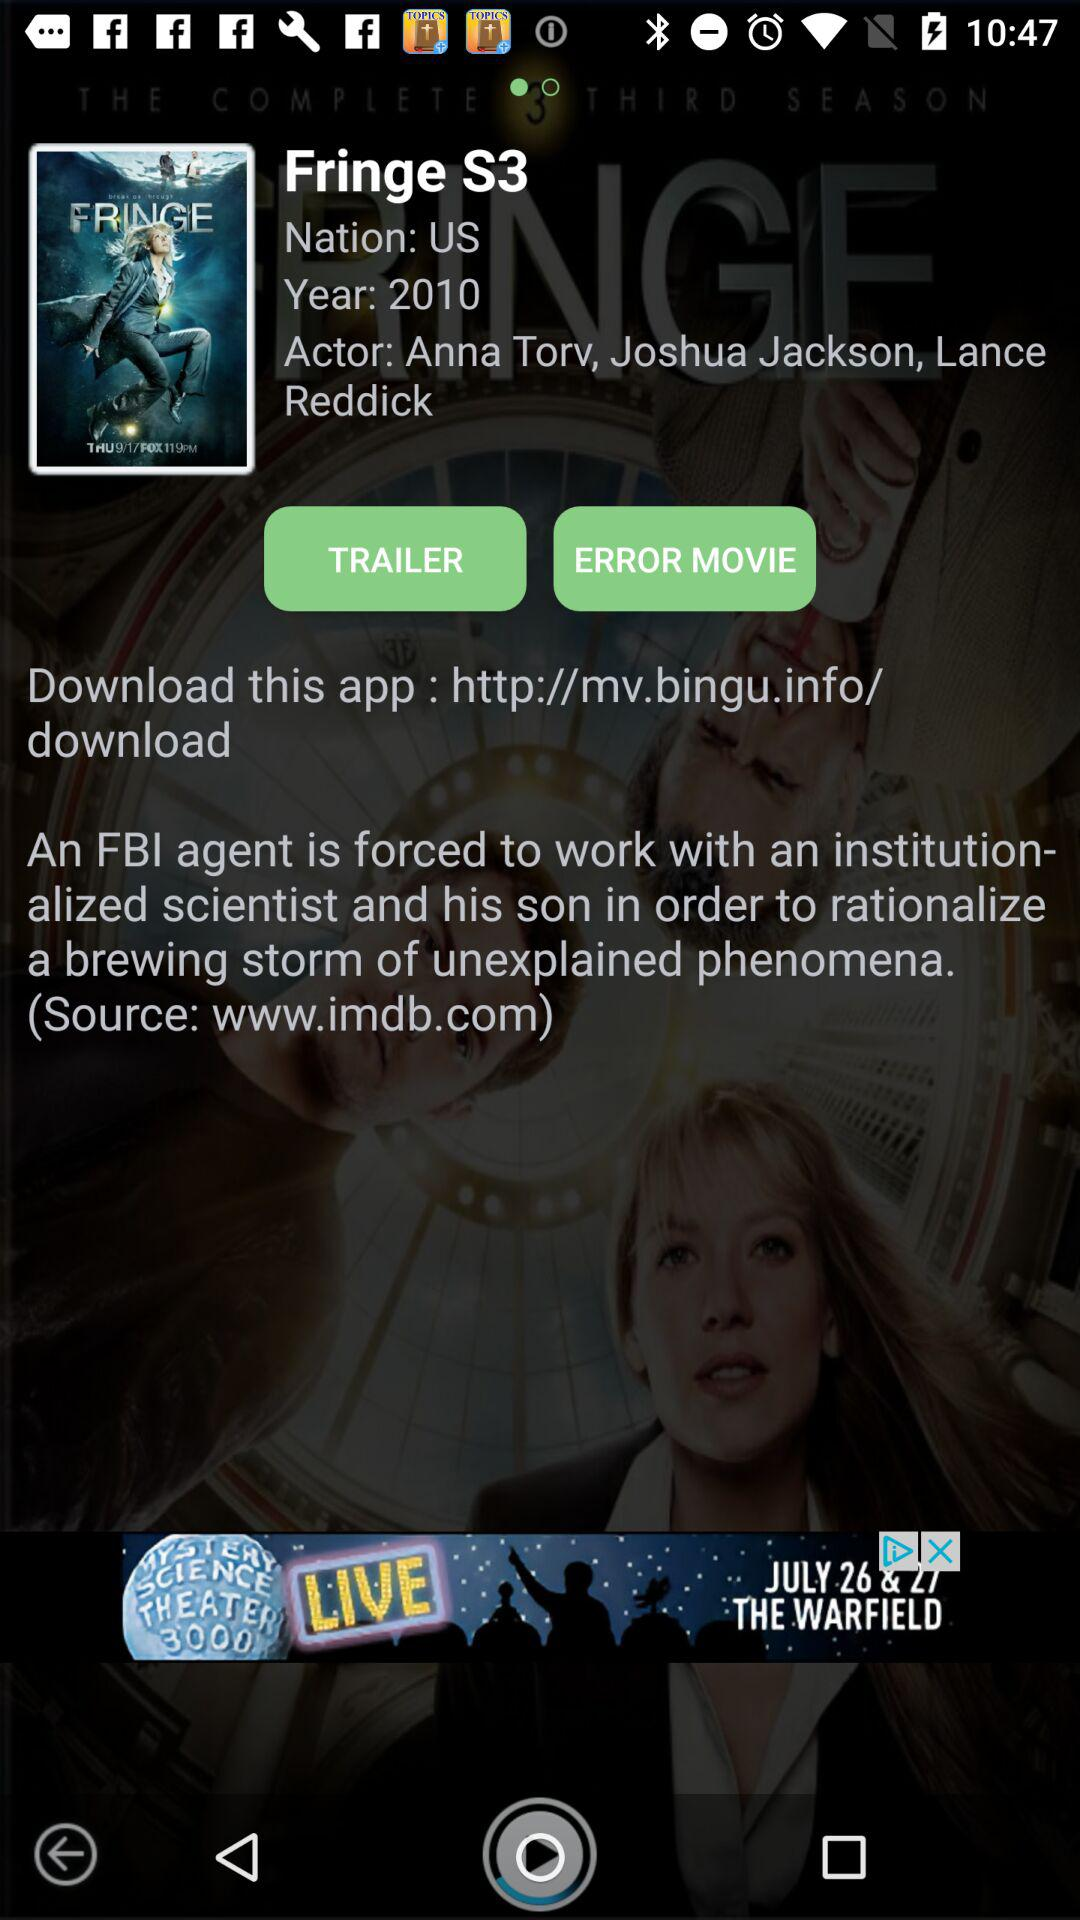What is the name of the series? The name of the series is "Fringe S3". 